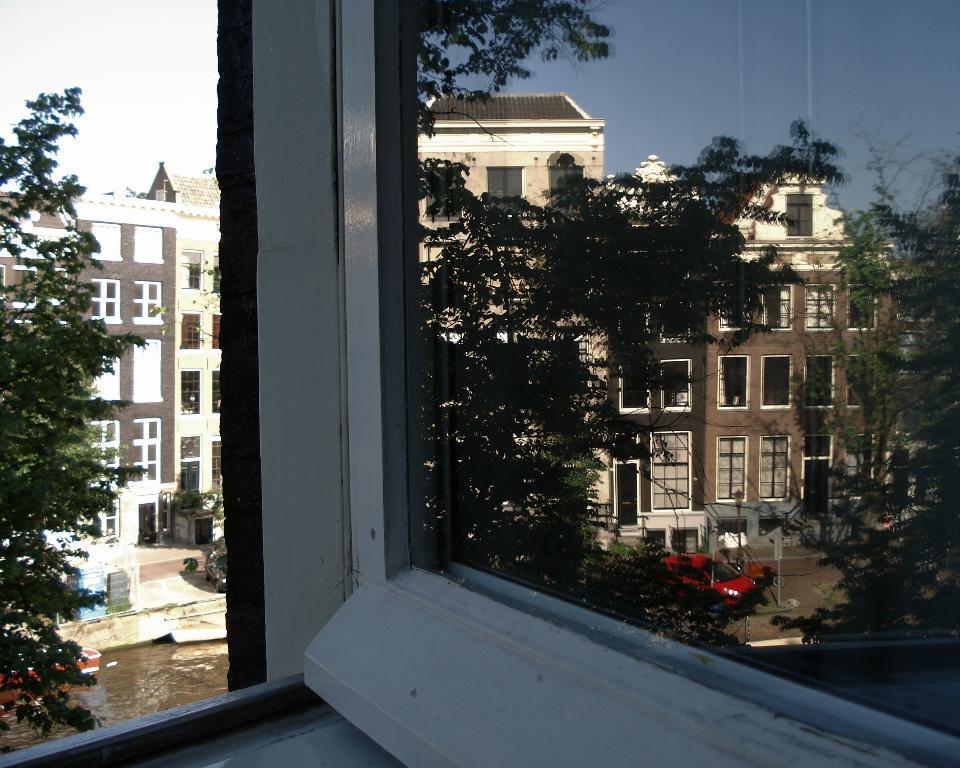Describe this image in one or two sentences. In this image we can see a glass window. And behind we can see vehicles, buildings. And we can see the sky. 